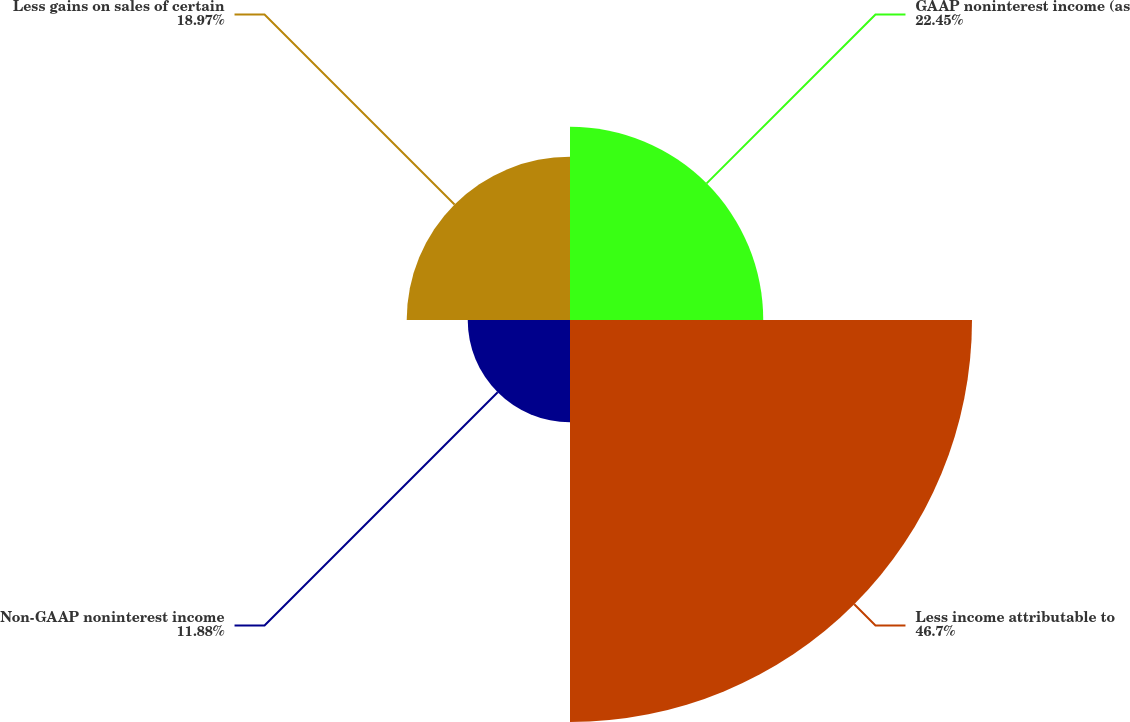Convert chart. <chart><loc_0><loc_0><loc_500><loc_500><pie_chart><fcel>GAAP noninterest income (as<fcel>Less income attributable to<fcel>Non-GAAP noninterest income<fcel>Less gains on sales of certain<nl><fcel>22.45%<fcel>46.7%<fcel>11.88%<fcel>18.97%<nl></chart> 